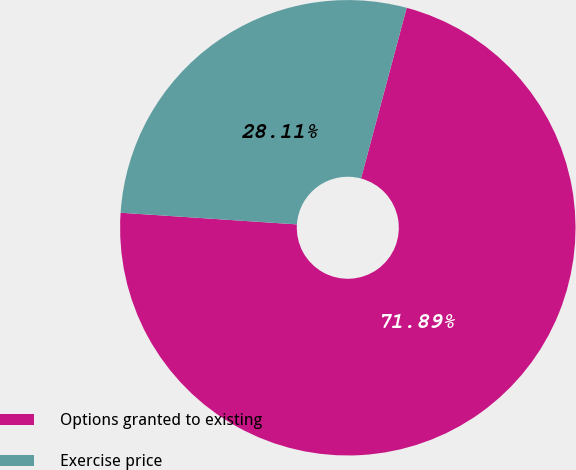Convert chart. <chart><loc_0><loc_0><loc_500><loc_500><pie_chart><fcel>Options granted to existing<fcel>Exercise price<nl><fcel>71.89%<fcel>28.11%<nl></chart> 